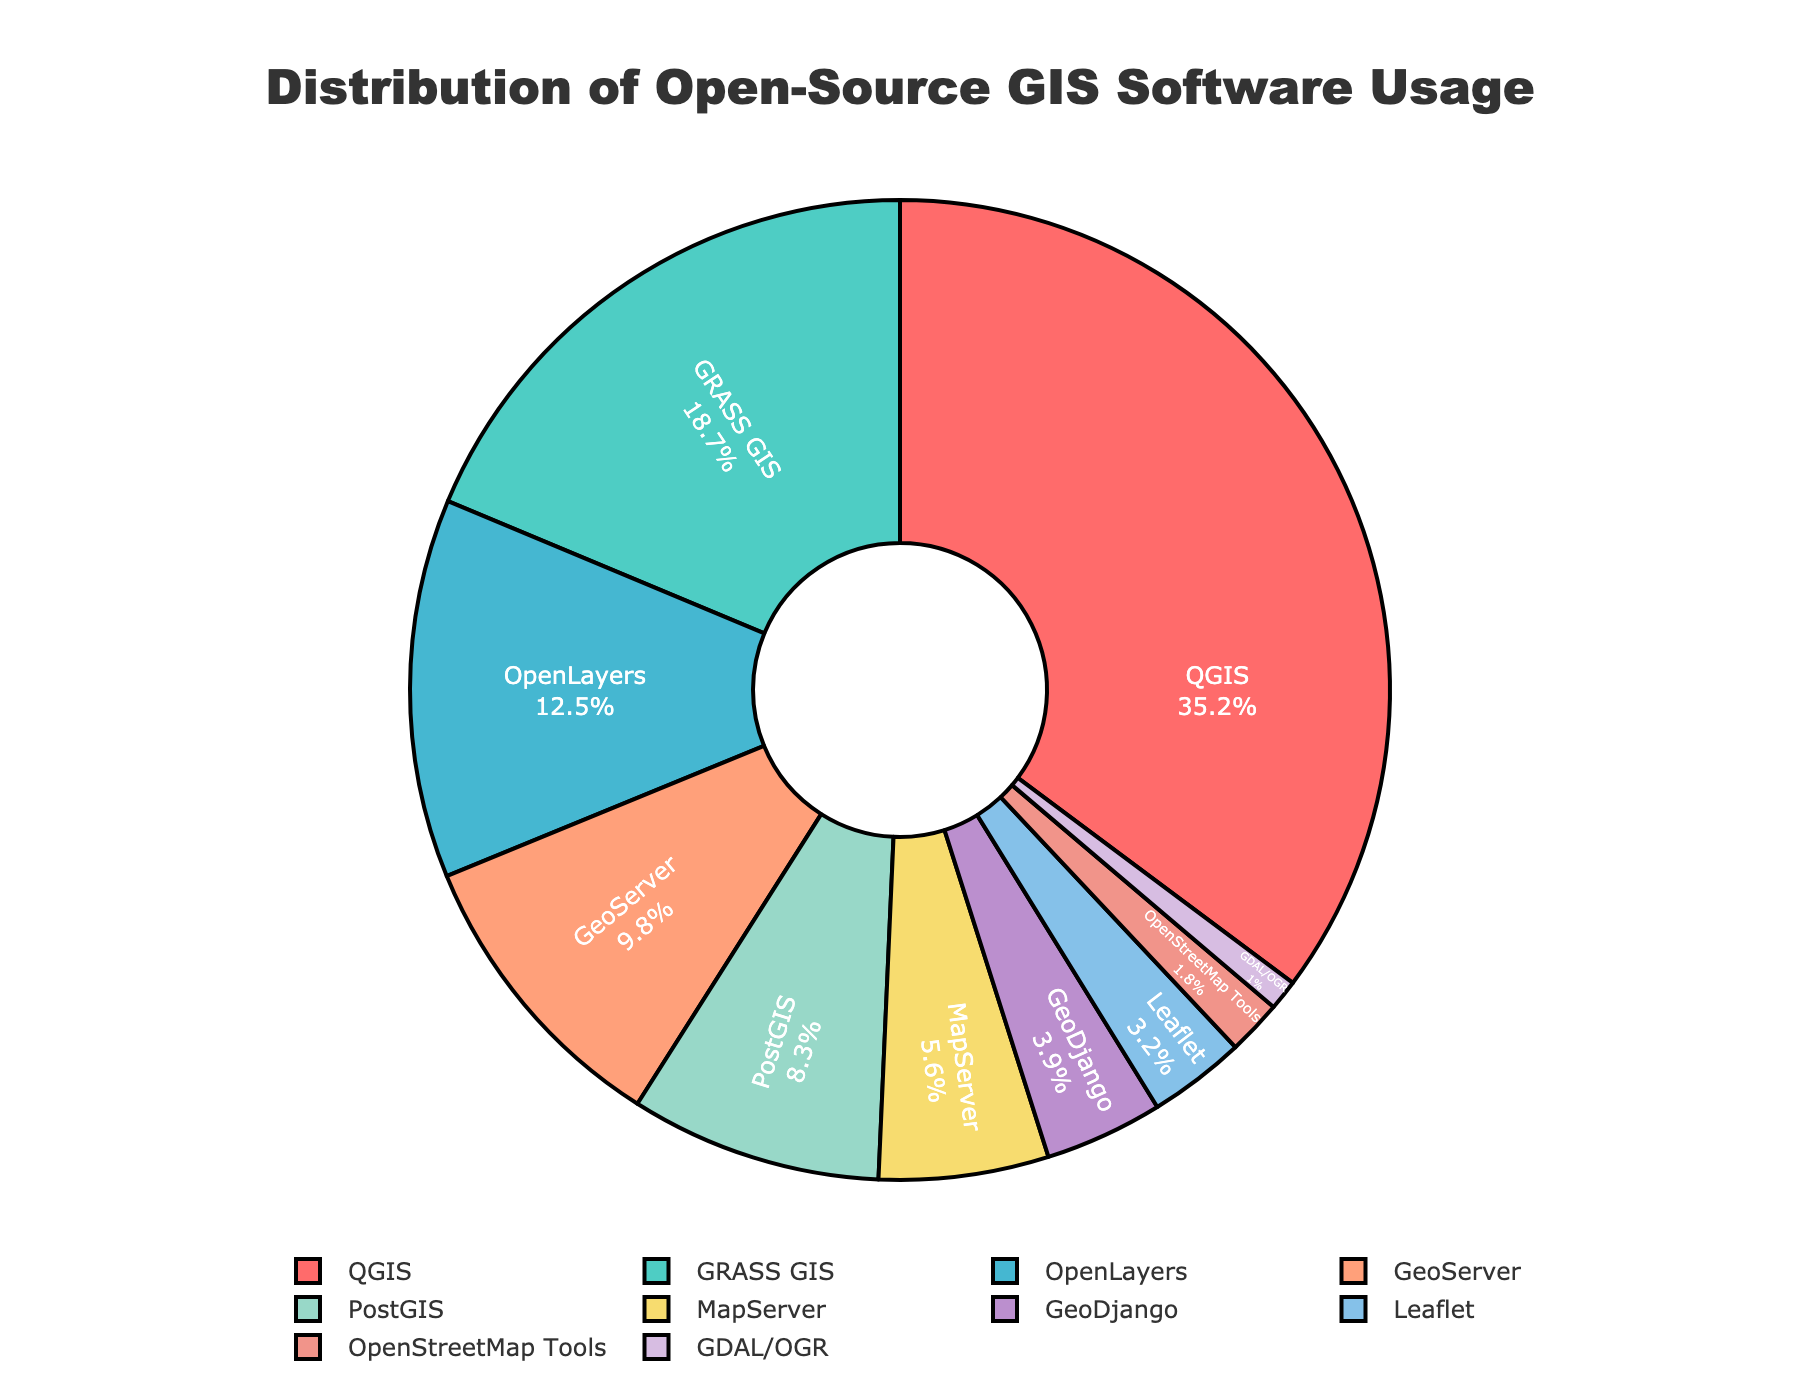What's the total usage percentage of the three least used application types? The three least used application types are GDAL/OGR (1%), OpenStreetMap Tools (1.8%), and Leaflet (3.2%). Summing these percentages: 1 + 1.8 + 3.2 = 6
Answer: 6 Which application type has the highest usage percentage? The application type with the highest usage percentage, as shown in the pie chart, is QGIS with 35.2%.
Answer: QGIS How much greater is the usage percentage of QGIS compared to GRASS GIS? QGIS has a usage percentage of 35.2%, and GRASS GIS has 18.7%. The difference between them is 35.2 - 18.7 = 16.5.
Answer: 16.5 Which application types have a usage percentage above 10%? The application types with usage percentages above 10% are QGIS (35.2%) and OpenLayers (12.5%).
Answer: QGIS, OpenLayers Are there more application types with usage percentages above 5% or below 5%? Above 5%: QGIS (35.2%), GRASS GIS (18.7%), OpenLayers (12.5%), GeoServer (9.8%), PostGIS (8.3%), MapServer (5.6%) - Total 6. Below 5%: GeoDjango (3.9%), Leaflet (3.2%), OpenStreetMap Tools (1.8%), GDAL/OGR (1%) - Total 4. There are more application types with usage percentages above 5%.
Answer: Above 5% What’s the usage percentage difference between MapServer and GeoDjango? MapServer has a usage percentage of 5.6% and GeoDjango has 3.9%. The difference is 5.6 - 3.9 = 1.7.
Answer: 1.7 Do GRASS GIS and PostGIS together account for more or less than 27% of the total usage? GRASS GIS accounts for 18.7% and PostGIS for 8.3%. Together, they account for 18.7 + 8.3 = 27%. Hence, they account for exactly 27%.
Answer: 27% Which application type is represented using a green color in the pie chart? Based on the custom color palette provided in the code, the color green corresponds to the second color assigned, which is GRASS GIS.
Answer: GRASS GIS If the usage percentages of OpenLayers and GeoServer were switched, which application type would then rank third in usage? Currently, the top three are QGIS (35.2%), GRASS GIS (18.7%), OpenLayers (12.5%). If OpenLayers (12.5%) and GeoServer (9.8%) are switched, GeoServer would have 12.5%. Hence, the new top three would be QGIS, GRASS GIS, and GeoServer (12.5%).
Answer: GeoServer 